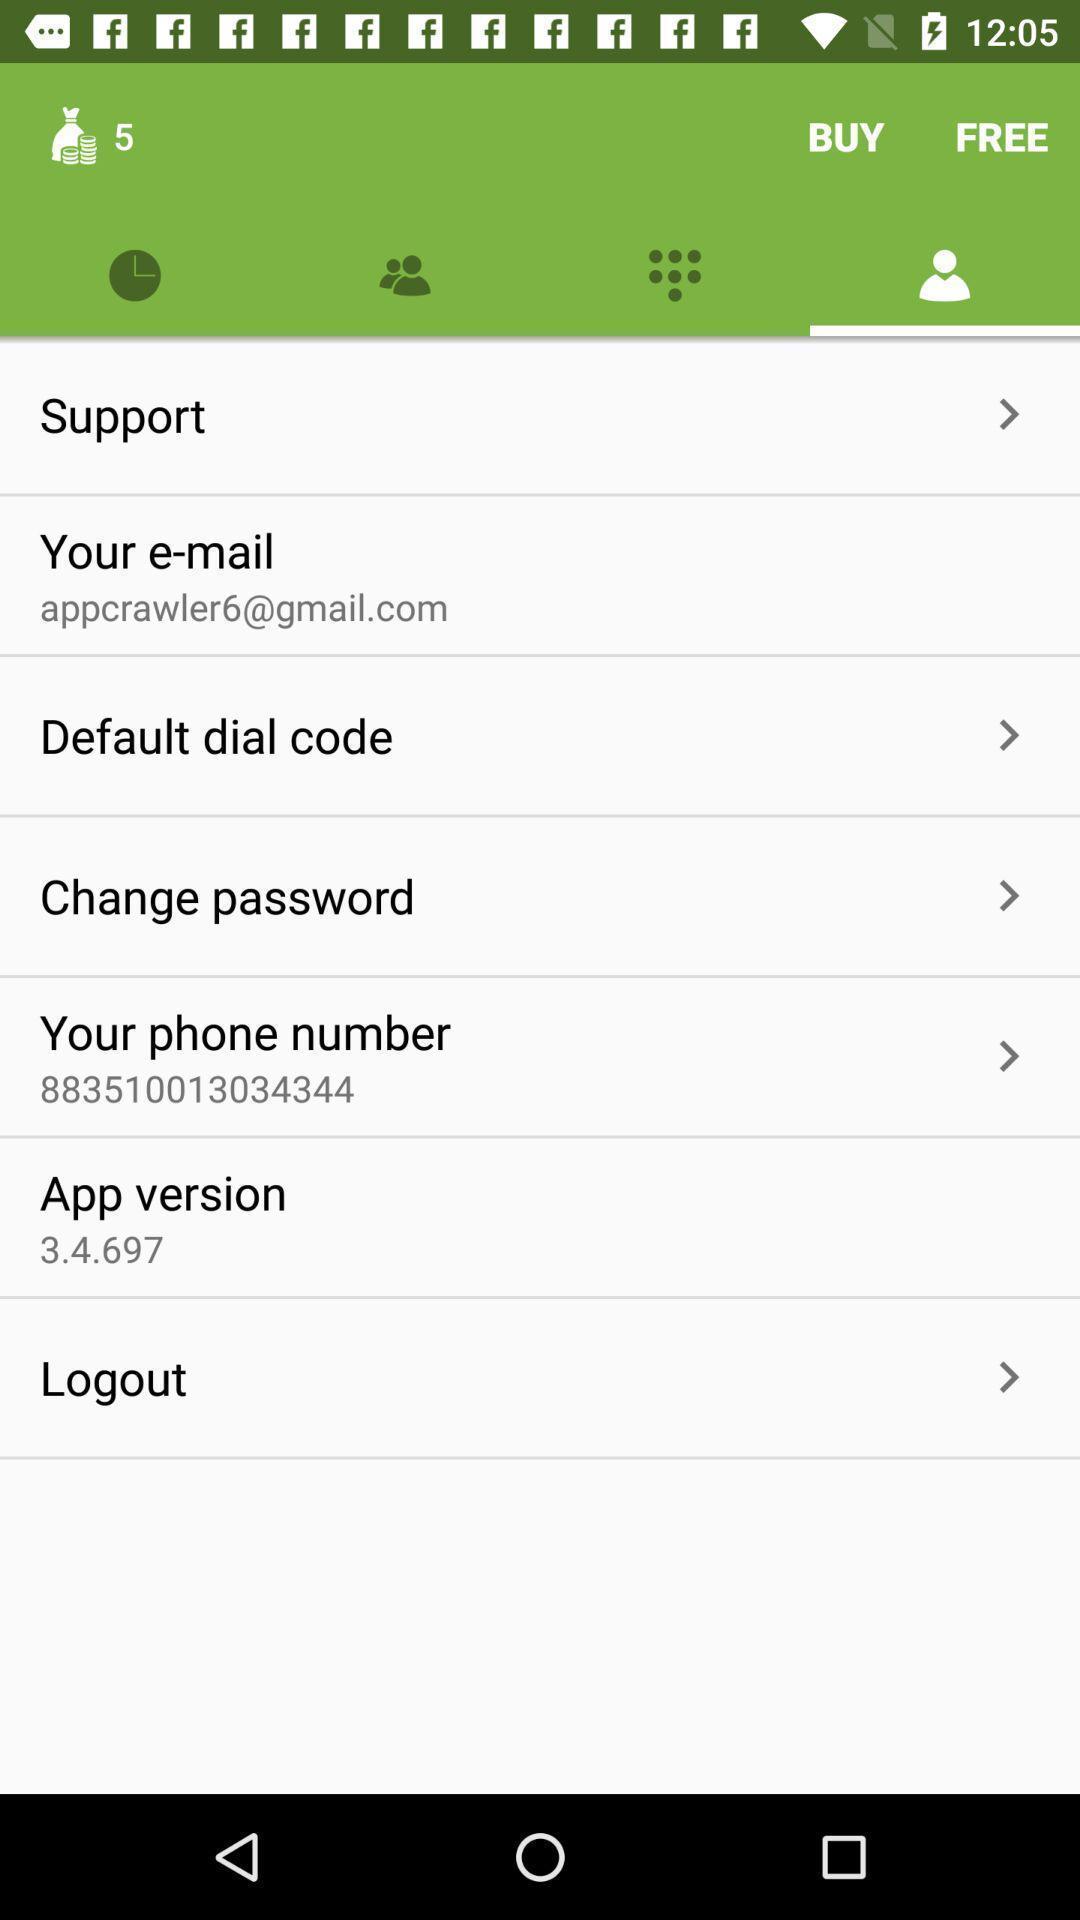Tell me what you see in this picture. Profile page. 